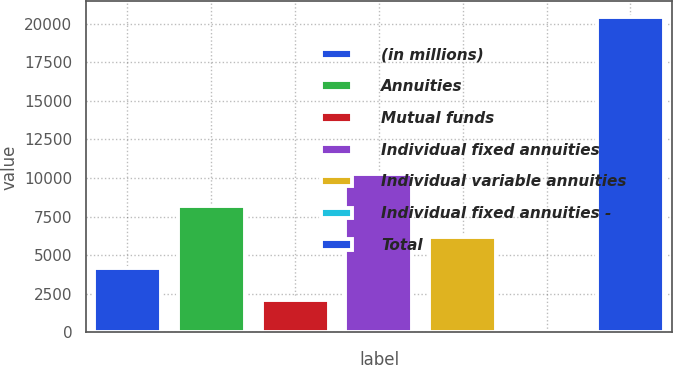Convert chart. <chart><loc_0><loc_0><loc_500><loc_500><bar_chart><fcel>(in millions)<fcel>Annuities<fcel>Mutual funds<fcel>Individual fixed annuities<fcel>Individual variable annuities<fcel>Individual fixed annuities -<fcel>Total<nl><fcel>4145.2<fcel>8213.4<fcel>2111.1<fcel>10247.5<fcel>6179.3<fcel>77<fcel>20418<nl></chart> 